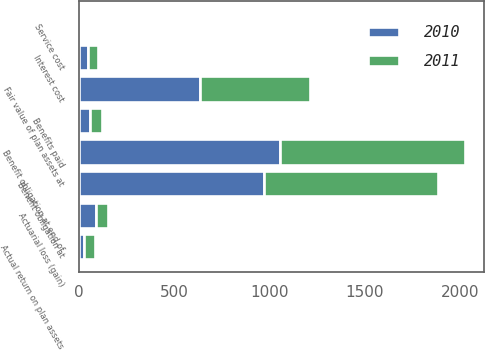Convert chart. <chart><loc_0><loc_0><loc_500><loc_500><stacked_bar_chart><ecel><fcel>Benefit obligation at<fcel>Service cost<fcel>Interest cost<fcel>Actuarial loss (gain)<fcel>Benefits paid<fcel>Benefit obligation at end of<fcel>Fair value of plan assets at<fcel>Actual return on plan assets<nl><fcel>2010<fcel>969.6<fcel>4.3<fcel>49.4<fcel>88.6<fcel>57.3<fcel>1054.9<fcel>635<fcel>29<nl><fcel>2011<fcel>910.8<fcel>4<fcel>50.6<fcel>67.2<fcel>63<fcel>969.6<fcel>576.9<fcel>59<nl></chart> 